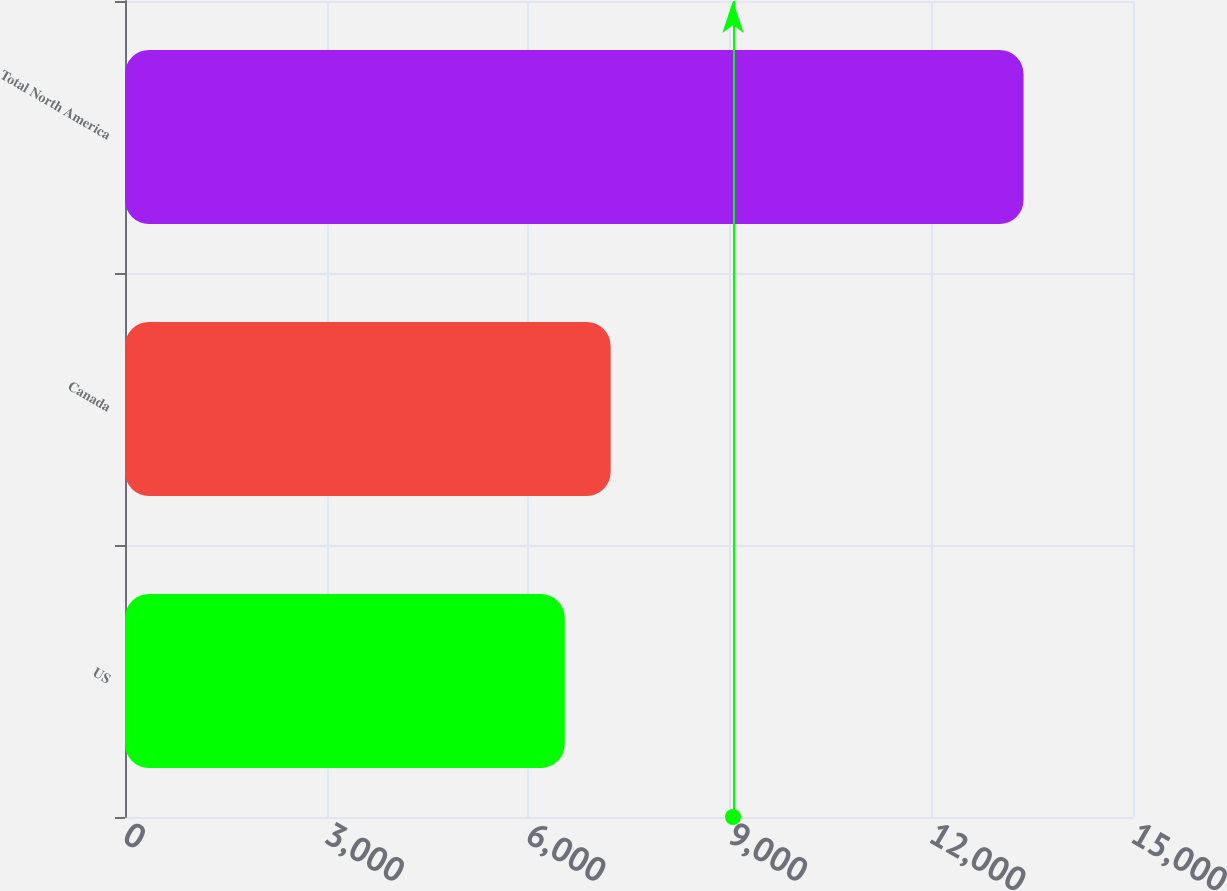Convert chart. <chart><loc_0><loc_0><loc_500><loc_500><bar_chart><fcel>US<fcel>Canada<fcel>Total North America<nl><fcel>6544<fcel>7226.7<fcel>13371<nl></chart> 